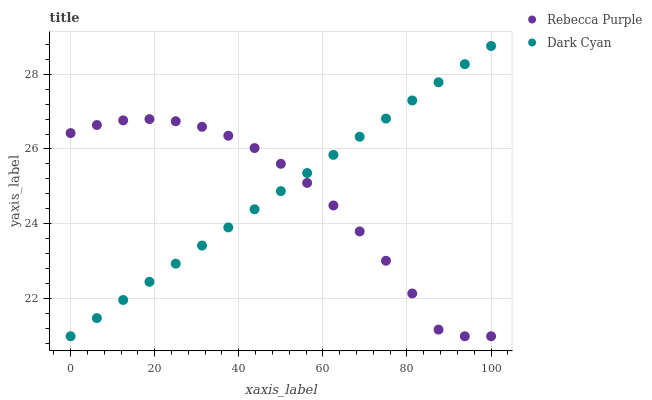Does Rebecca Purple have the minimum area under the curve?
Answer yes or no. Yes. Does Dark Cyan have the maximum area under the curve?
Answer yes or no. Yes. Does Rebecca Purple have the maximum area under the curve?
Answer yes or no. No. Is Dark Cyan the smoothest?
Answer yes or no. Yes. Is Rebecca Purple the roughest?
Answer yes or no. Yes. Is Rebecca Purple the smoothest?
Answer yes or no. No. Does Dark Cyan have the lowest value?
Answer yes or no. Yes. Does Dark Cyan have the highest value?
Answer yes or no. Yes. Does Rebecca Purple have the highest value?
Answer yes or no. No. Does Rebecca Purple intersect Dark Cyan?
Answer yes or no. Yes. Is Rebecca Purple less than Dark Cyan?
Answer yes or no. No. Is Rebecca Purple greater than Dark Cyan?
Answer yes or no. No. 